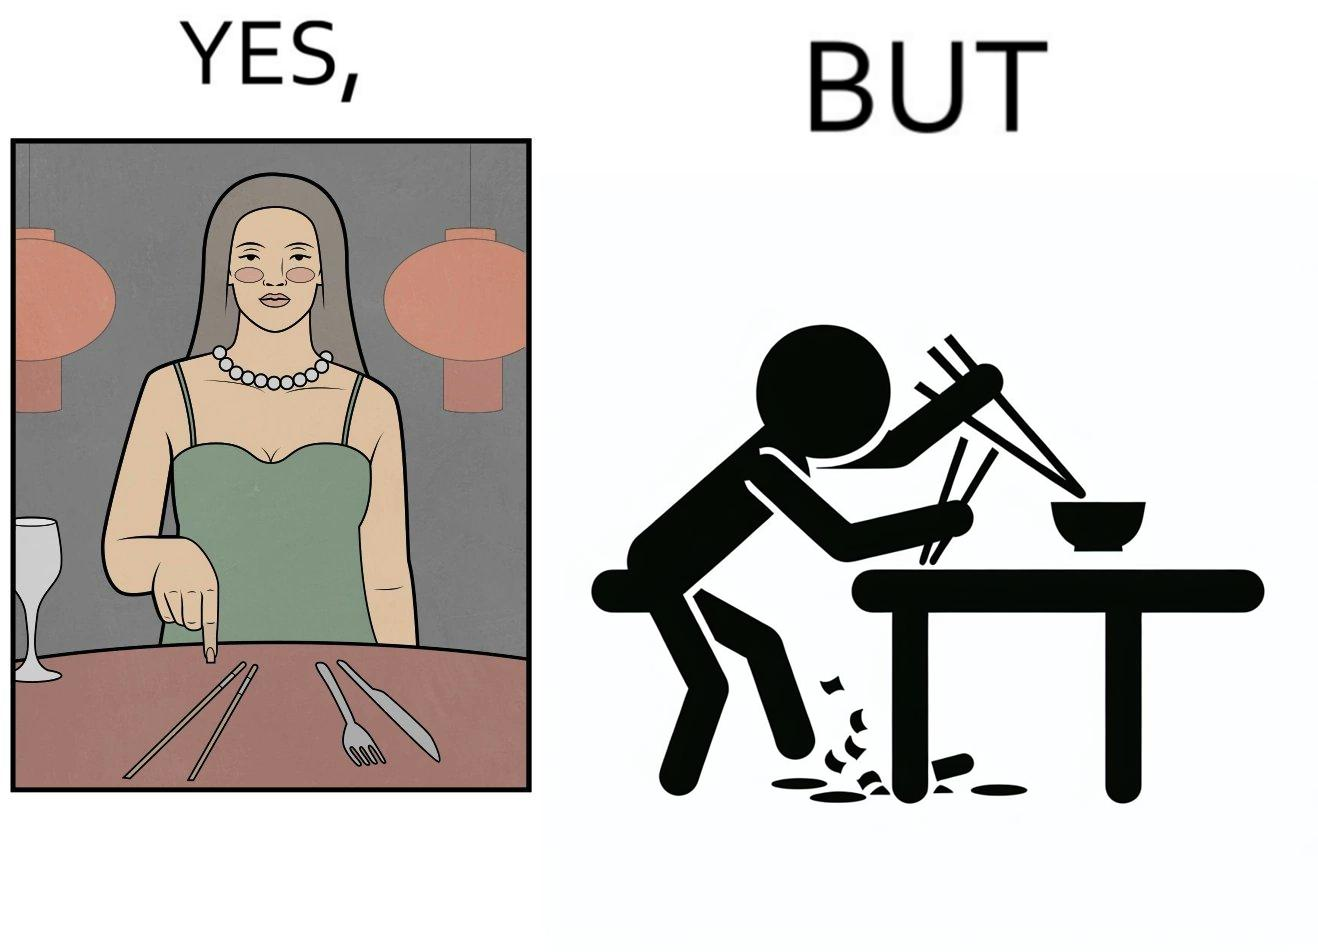Provide a description of this image. The image is satirical because even thought the woman is not able to eat food with chopstick properly, she chooses it over fork and knife to look sophisticaed. 